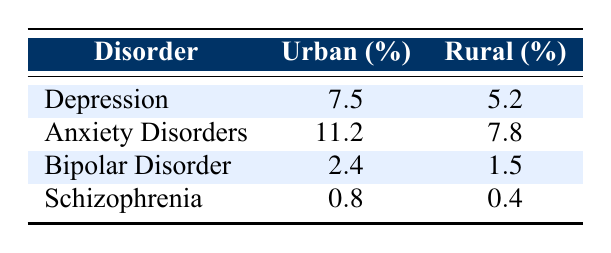What is the prevalence rate of depression in the urban population? The table shows that the prevalence rate for depression in the urban population is listed under the "Urban (%)" column corresponding to the "Depression" row. It is clearly noted as 7.5 percent.
Answer: 7.5 What is the prevalence rate of anxiety disorders in the rural population? Referring to the table, the prevalence rate for anxiety disorders in the rural population can be found in the "Rural (%)" column next to the "Anxiety Disorders" row, which is 7.8 percent.
Answer: 7.8 Is the prevalence of bipolar disorder higher in urban or rural populations? To determine which population has a higher prevalence of bipolar disorder, we compare the two rates: 2.4 percent for urban and 1.5 percent for rural. Since 2.4 is greater than 1.5, urban populations have a higher prevalence.
Answer: Yes What is the difference in the prevalence rate of schizophrenia between urban and rural populations? To find the difference, we take the prevalence rate in urban (0.8 percent) and subtract it from the rural prevalence rate (0.4 percent). The calculation is 0.8 - 0.4 = 0.4 percent.
Answer: 0.4 What is the average prevalence rate of anxiety disorders and depression in urban populations? First, we identify the rates for urban populations: depression is 7.5 and anxiety disorders is 11.2. We sum these values: 7.5 + 11.2 = 18.7. Then, we divide by 2 for the average: 18.7 / 2 = 9.35.
Answer: 9.35 Does the prevalence rate of schizophrenia in the urban population exceed that of bipolar disorder? Looking at the schizophrenia rate for the urban population (0.8 percent) and comparing it to the bipolar disorder rate (2.4 percent), we see that 0.8 is indeed less than 2.4. Thus, the statement is false.
Answer: No What is the total combined prevalence rate of depression and anxiety disorders in rural populations? To find the total for rural populations, we add the prevalence rates for depression (5.2) and anxiety disorders (7.8) together: 5.2 + 7.8 = 13.0 percent.
Answer: 13.0 Which mental health disorder has the lowest prevalence rate in the rural population? In the rural population's data, we examine the rates listed: depression (5.2), anxiety disorders (7.8), bipolar disorder (1.5), and schizophrenia (0.4). The lowest value is 0.4, which corresponds to schizophrenia.
Answer: Schizophrenia What percentage of anxiety disorders prevalence is represented by urban populations compared to rural populations? We start by comparing the urban prevalence rate of anxiety disorders (11.2) to the rural rate (7.8). The proportion is calculated as follows: (11.2 / 7.8) * 100, which gives approximately 143.6 percent. Urban prevalence is about 143.6 percent of rural prevalence.
Answer: 143.6 percent 